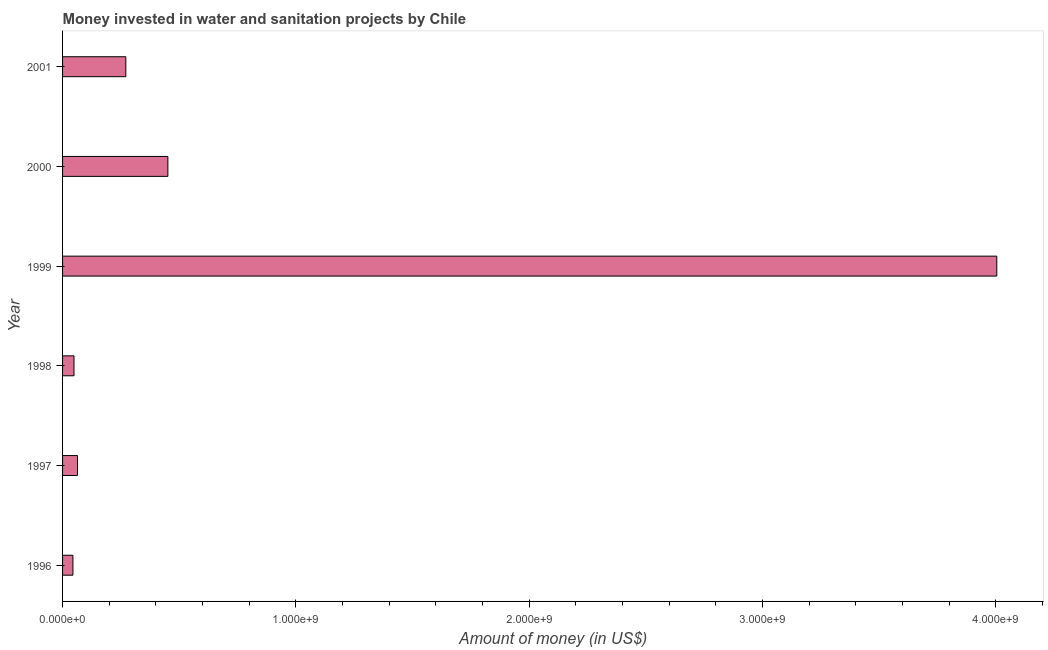Does the graph contain grids?
Give a very brief answer. No. What is the title of the graph?
Provide a succinct answer. Money invested in water and sanitation projects by Chile. What is the label or title of the X-axis?
Provide a succinct answer. Amount of money (in US$). What is the investment in 2001?
Your answer should be very brief. 2.71e+08. Across all years, what is the maximum investment?
Provide a succinct answer. 4.00e+09. Across all years, what is the minimum investment?
Your answer should be compact. 4.44e+07. In which year was the investment maximum?
Offer a very short reply. 1999. In which year was the investment minimum?
Make the answer very short. 1996. What is the sum of the investment?
Your response must be concise. 4.88e+09. What is the difference between the investment in 1996 and 2001?
Offer a very short reply. -2.27e+08. What is the average investment per year?
Your response must be concise. 8.14e+08. What is the median investment?
Offer a very short reply. 1.68e+08. Do a majority of the years between 1999 and 2000 (inclusive) have investment greater than 2200000000 US$?
Offer a terse response. No. What is the ratio of the investment in 1996 to that in 1997?
Your response must be concise. 0.69. Is the difference between the investment in 1996 and 1997 greater than the difference between any two years?
Give a very brief answer. No. What is the difference between the highest and the second highest investment?
Make the answer very short. 3.55e+09. What is the difference between the highest and the lowest investment?
Give a very brief answer. 3.96e+09. How many bars are there?
Make the answer very short. 6. Are all the bars in the graph horizontal?
Offer a very short reply. Yes. How many years are there in the graph?
Your answer should be very brief. 6. What is the difference between two consecutive major ticks on the X-axis?
Offer a very short reply. 1.00e+09. Are the values on the major ticks of X-axis written in scientific E-notation?
Keep it short and to the point. Yes. What is the Amount of money (in US$) in 1996?
Provide a succinct answer. 4.44e+07. What is the Amount of money (in US$) in 1997?
Give a very brief answer. 6.40e+07. What is the Amount of money (in US$) in 1998?
Your answer should be compact. 4.90e+07. What is the Amount of money (in US$) in 1999?
Provide a short and direct response. 4.00e+09. What is the Amount of money (in US$) in 2000?
Offer a very short reply. 4.51e+08. What is the Amount of money (in US$) in 2001?
Offer a terse response. 2.71e+08. What is the difference between the Amount of money (in US$) in 1996 and 1997?
Your answer should be compact. -1.96e+07. What is the difference between the Amount of money (in US$) in 1996 and 1998?
Ensure brevity in your answer.  -4.60e+06. What is the difference between the Amount of money (in US$) in 1996 and 1999?
Your answer should be very brief. -3.96e+09. What is the difference between the Amount of money (in US$) in 1996 and 2000?
Your answer should be very brief. -4.07e+08. What is the difference between the Amount of money (in US$) in 1996 and 2001?
Your answer should be very brief. -2.27e+08. What is the difference between the Amount of money (in US$) in 1997 and 1998?
Your answer should be compact. 1.50e+07. What is the difference between the Amount of money (in US$) in 1997 and 1999?
Provide a succinct answer. -3.94e+09. What is the difference between the Amount of money (in US$) in 1997 and 2000?
Your answer should be very brief. -3.87e+08. What is the difference between the Amount of money (in US$) in 1997 and 2001?
Your answer should be very brief. -2.07e+08. What is the difference between the Amount of money (in US$) in 1998 and 1999?
Your answer should be compact. -3.95e+09. What is the difference between the Amount of money (in US$) in 1998 and 2000?
Your response must be concise. -4.02e+08. What is the difference between the Amount of money (in US$) in 1998 and 2001?
Provide a short and direct response. -2.22e+08. What is the difference between the Amount of money (in US$) in 1999 and 2000?
Your response must be concise. 3.55e+09. What is the difference between the Amount of money (in US$) in 1999 and 2001?
Your response must be concise. 3.73e+09. What is the difference between the Amount of money (in US$) in 2000 and 2001?
Your answer should be very brief. 1.80e+08. What is the ratio of the Amount of money (in US$) in 1996 to that in 1997?
Provide a succinct answer. 0.69. What is the ratio of the Amount of money (in US$) in 1996 to that in 1998?
Offer a terse response. 0.91. What is the ratio of the Amount of money (in US$) in 1996 to that in 1999?
Give a very brief answer. 0.01. What is the ratio of the Amount of money (in US$) in 1996 to that in 2000?
Offer a terse response. 0.1. What is the ratio of the Amount of money (in US$) in 1996 to that in 2001?
Your response must be concise. 0.16. What is the ratio of the Amount of money (in US$) in 1997 to that in 1998?
Provide a short and direct response. 1.31. What is the ratio of the Amount of money (in US$) in 1997 to that in 1999?
Your answer should be very brief. 0.02. What is the ratio of the Amount of money (in US$) in 1997 to that in 2000?
Offer a very short reply. 0.14. What is the ratio of the Amount of money (in US$) in 1997 to that in 2001?
Make the answer very short. 0.24. What is the ratio of the Amount of money (in US$) in 1998 to that in 1999?
Offer a terse response. 0.01. What is the ratio of the Amount of money (in US$) in 1998 to that in 2000?
Your answer should be compact. 0.11. What is the ratio of the Amount of money (in US$) in 1998 to that in 2001?
Ensure brevity in your answer.  0.18. What is the ratio of the Amount of money (in US$) in 1999 to that in 2000?
Give a very brief answer. 8.87. What is the ratio of the Amount of money (in US$) in 1999 to that in 2001?
Make the answer very short. 14.77. What is the ratio of the Amount of money (in US$) in 2000 to that in 2001?
Your response must be concise. 1.67. 